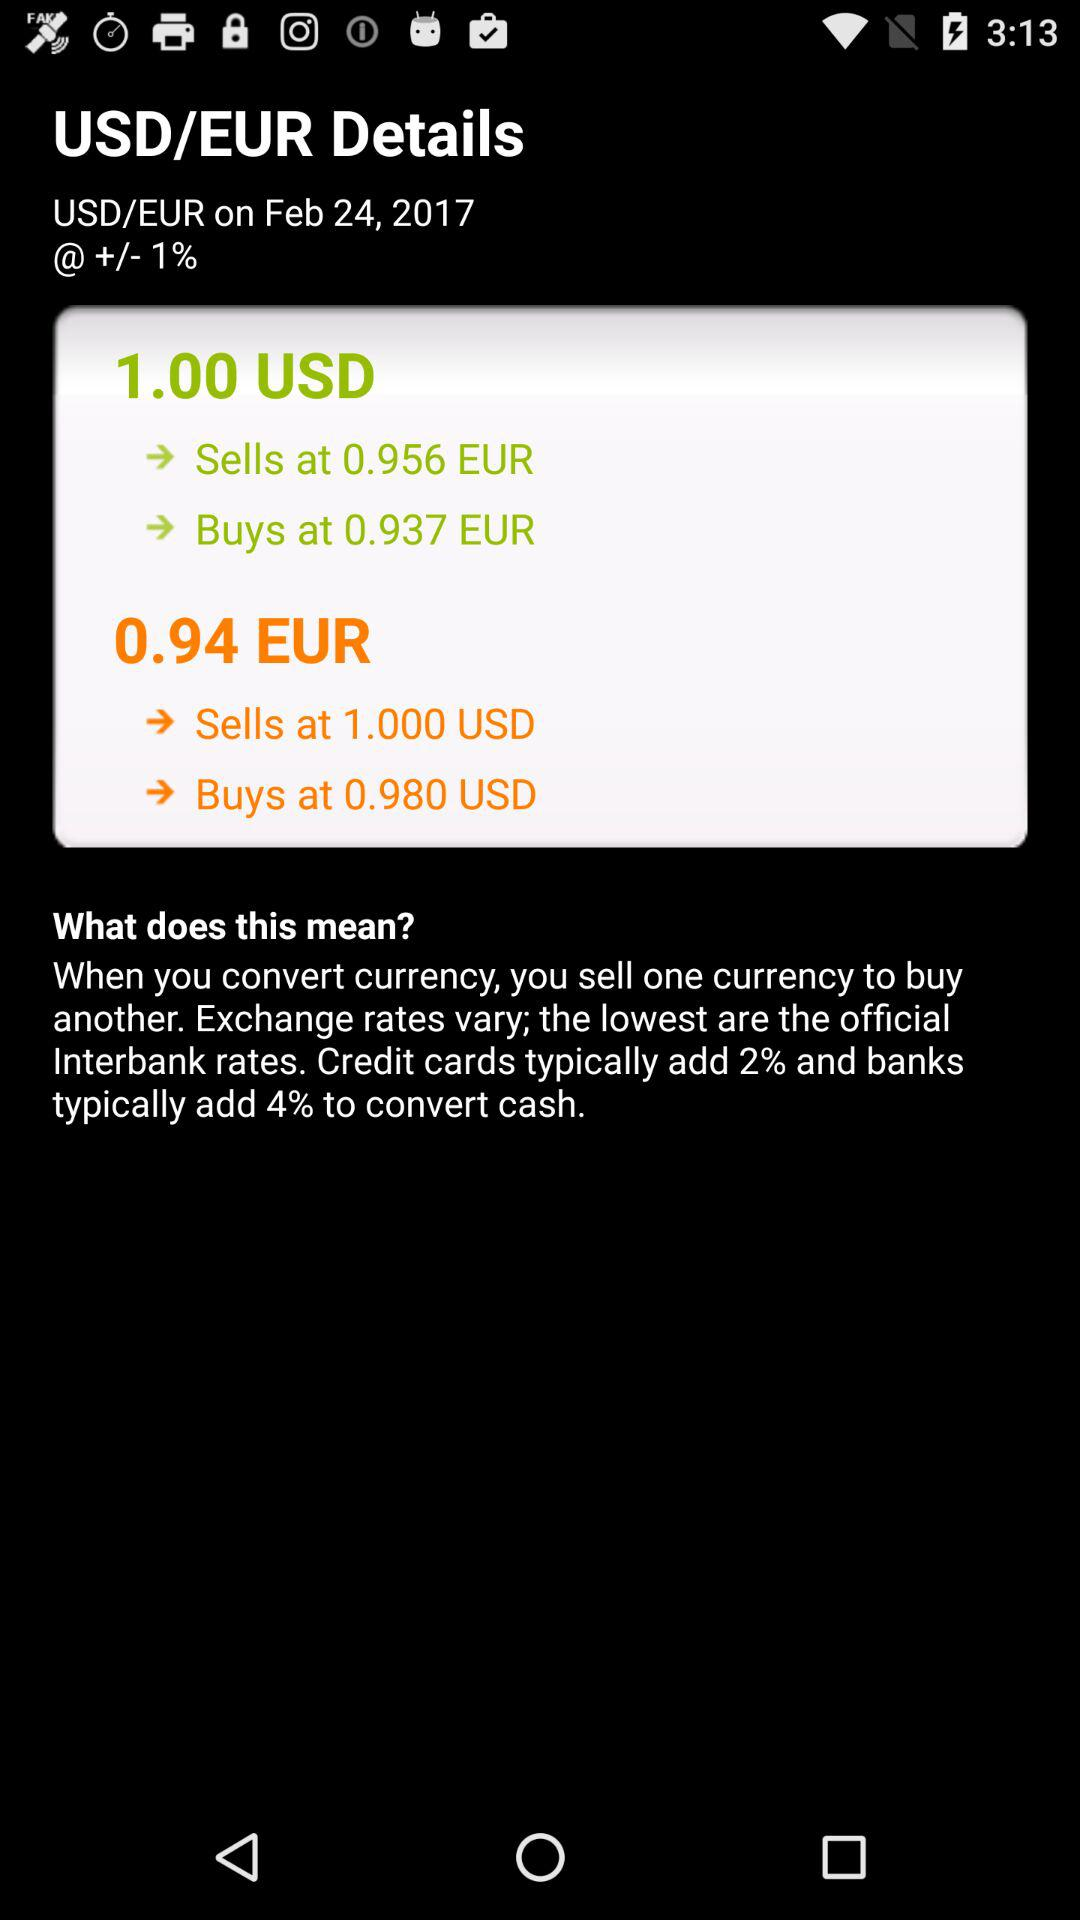For what date are the details shown? The date is February 24, 2017. 